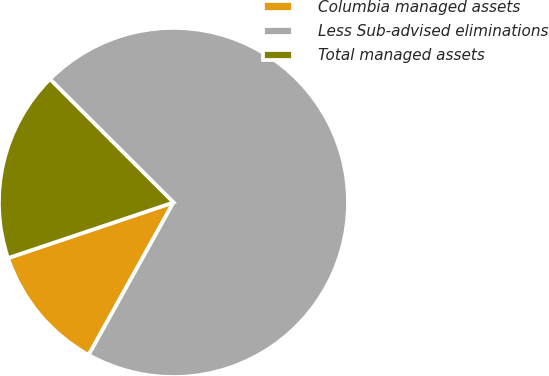Convert chart. <chart><loc_0><loc_0><loc_500><loc_500><pie_chart><fcel>Columbia managed assets<fcel>Less Sub-advised eliminations<fcel>Total managed assets<nl><fcel>11.76%<fcel>70.59%<fcel>17.65%<nl></chart> 